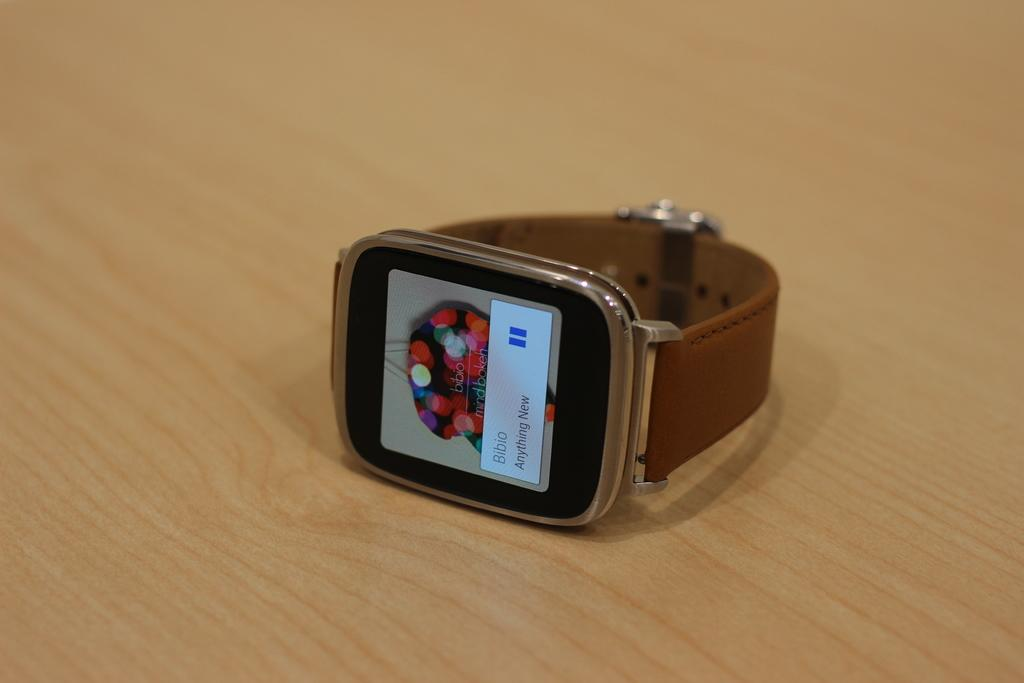What object can be seen in the image? There is a watch in the image. Where is the watch located? The watch is on a wooden surface. What color is the coal in the image? There is no coal present in the image. 